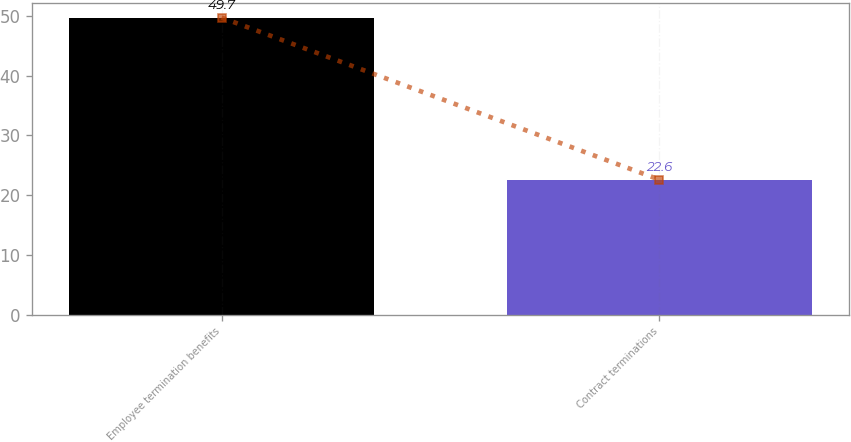Convert chart. <chart><loc_0><loc_0><loc_500><loc_500><bar_chart><fcel>Employee termination benefits<fcel>Contract terminations<nl><fcel>49.7<fcel>22.6<nl></chart> 